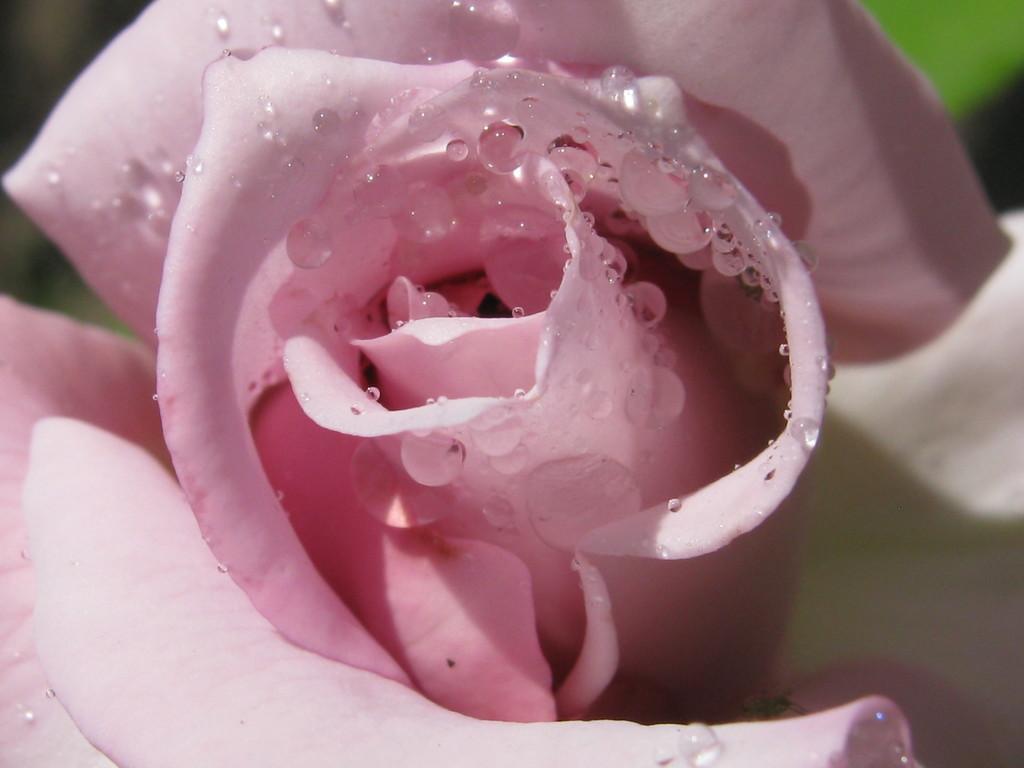In one or two sentences, can you explain what this image depicts? In this image I can see the flower which is in pink color. I can see the blurred background. 